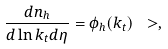<formula> <loc_0><loc_0><loc_500><loc_500>\frac { d n _ { h } } { d \ln k _ { t } d \eta } = \phi _ { h } ( k _ { t } ) \ > ,</formula> 